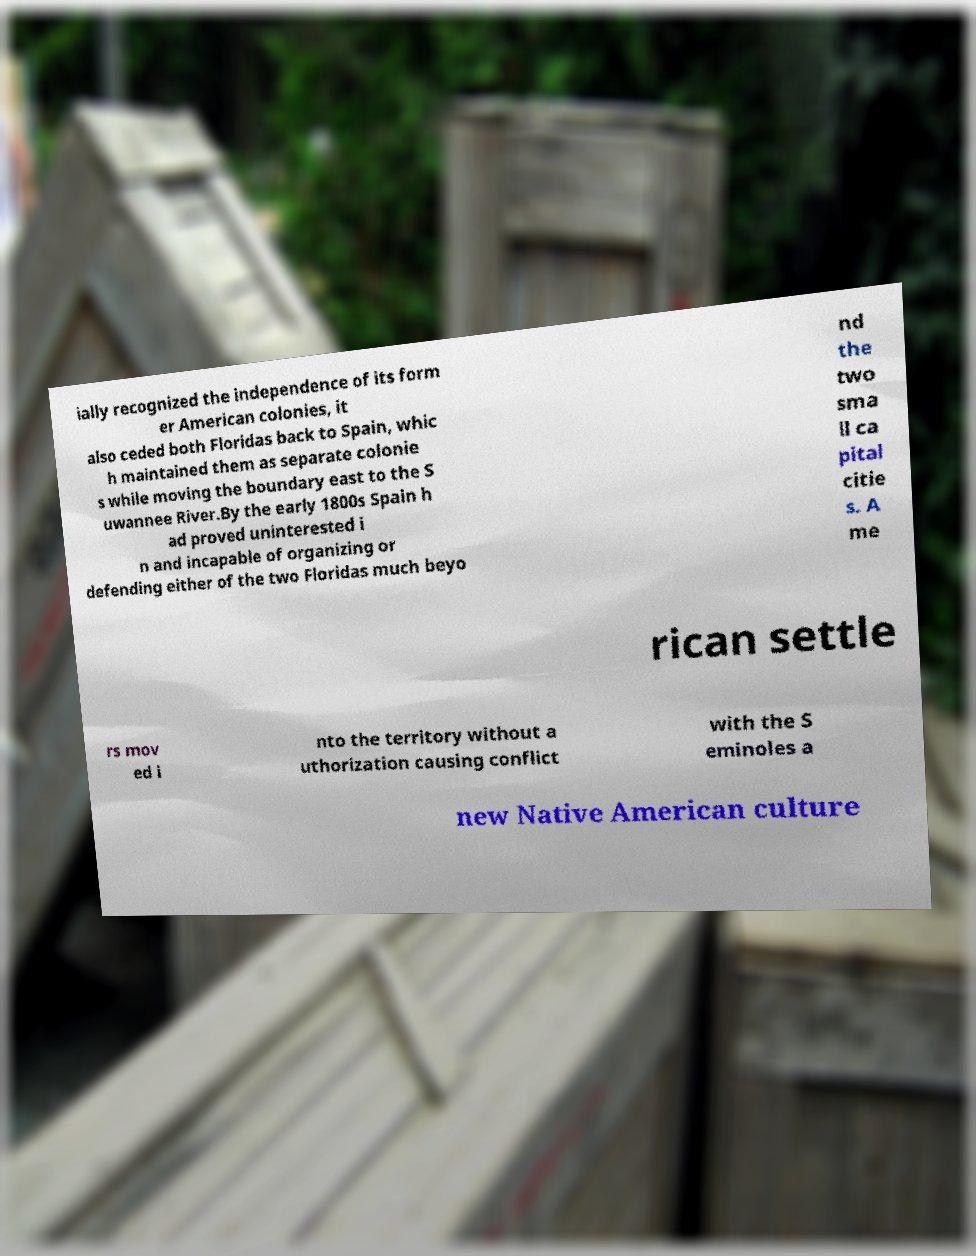There's text embedded in this image that I need extracted. Can you transcribe it verbatim? ially recognized the independence of its form er American colonies, it also ceded both Floridas back to Spain, whic h maintained them as separate colonie s while moving the boundary east to the S uwannee River.By the early 1800s Spain h ad proved uninterested i n and incapable of organizing or defending either of the two Floridas much beyo nd the two sma ll ca pital citie s. A me rican settle rs mov ed i nto the territory without a uthorization causing conflict with the S eminoles a new Native American culture 